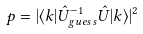Convert formula to latex. <formula><loc_0><loc_0><loc_500><loc_500>p = | \langle k | \hat { U } _ { g u e s s } ^ { - 1 } \hat { U } | k \rangle | ^ { 2 }</formula> 